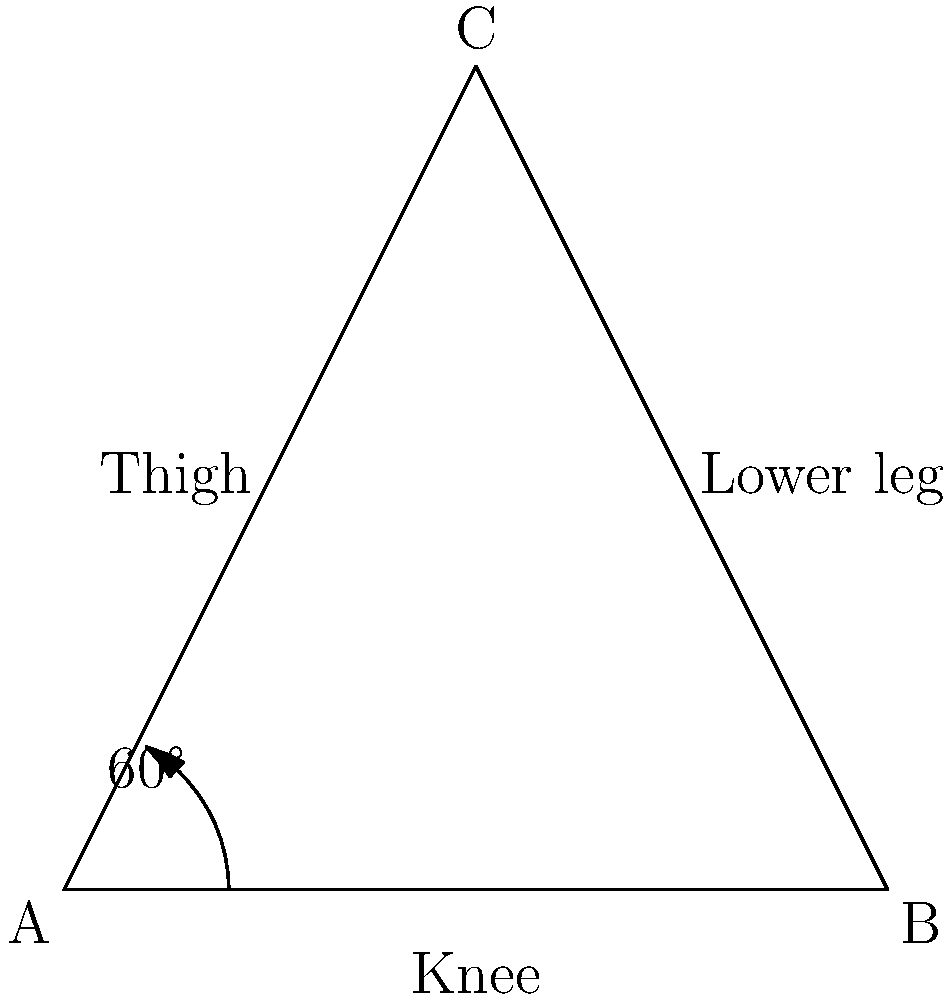The diagram shows a simplified representation of a child's leg during a swinging motion on a playground swing. The angle between the thigh and lower leg is 60°. If the full range of motion for the knee joint during this activity is from 0° (fully extended) to 135° (fully flexed), what percentage of the total range of motion is represented in this diagram? To solve this problem, we need to follow these steps:

1. Identify the total range of motion for the knee joint:
   Full extension (0°) to full flexion (135°)
   Total range = 135° - 0° = 135°

2. Identify the current angle in the diagram:
   The angle between the thigh and lower leg is 60°

3. Calculate the angle from full extension:
   Since 0° represents full extension, the current angle from full extension is 60°

4. Calculate the percentage of total range:
   Percentage = (Current angle / Total range) × 100
   Percentage = (60° / 135°) × 100
   Percentage = 0.4444... × 100 = 44.44%

5. Round to the nearest whole percentage:
   44%
Answer: 44% 